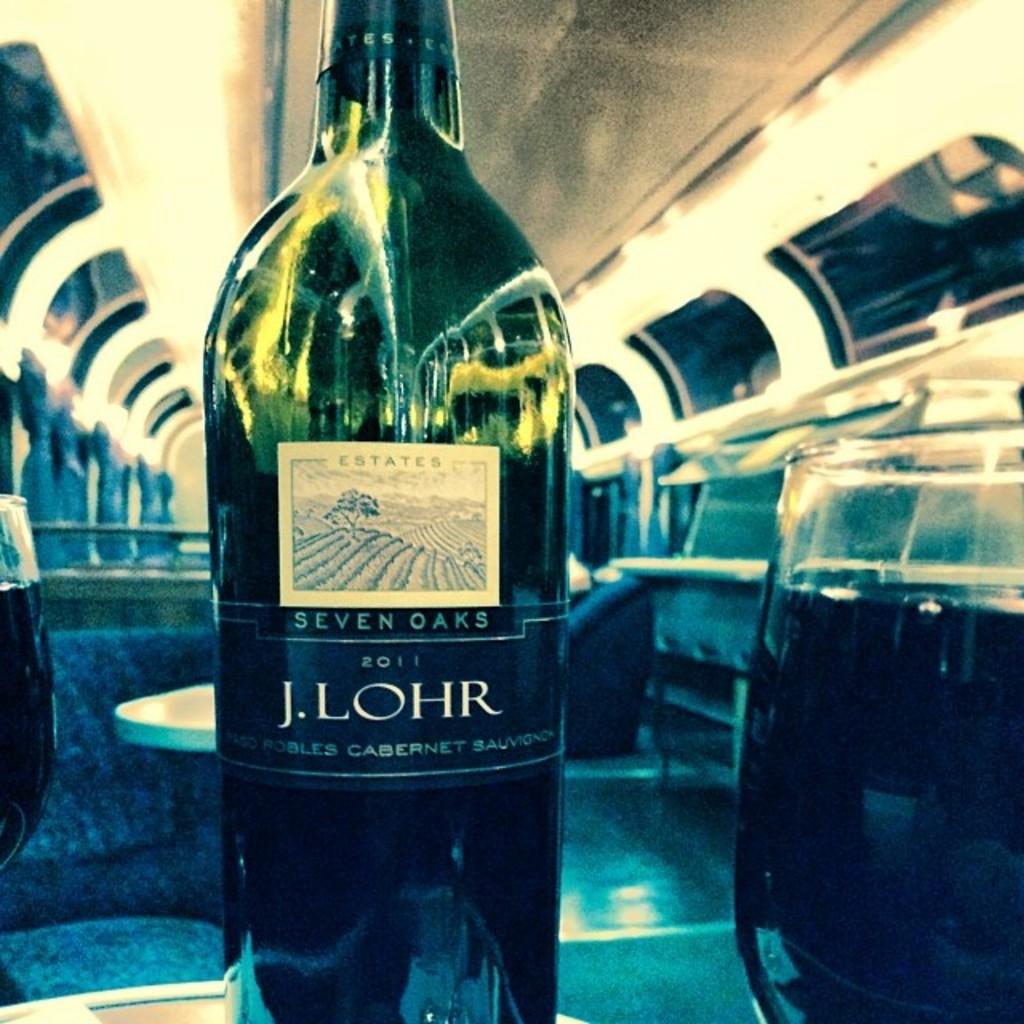What year is on the wine bottle?
Provide a succinct answer. 2011. 